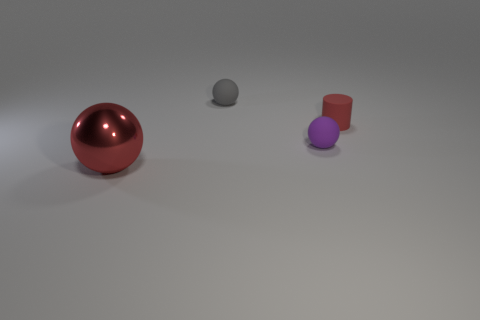There is a large metal ball; is its color the same as the tiny sphere behind the small purple matte thing? no 